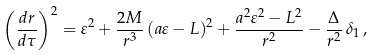Convert formula to latex. <formula><loc_0><loc_0><loc_500><loc_500>\left ( \frac { d r } { d \tau } \right ) ^ { 2 } = \varepsilon ^ { 2 } + \frac { 2 M } { r ^ { 3 } } \, ( a \varepsilon - L ) ^ { 2 } + \frac { a ^ { 2 } \varepsilon ^ { 2 } - L ^ { 2 } } { r ^ { 2 } } - \frac { \Delta } { r ^ { 2 } } \, \delta _ { 1 } \, ,</formula> 